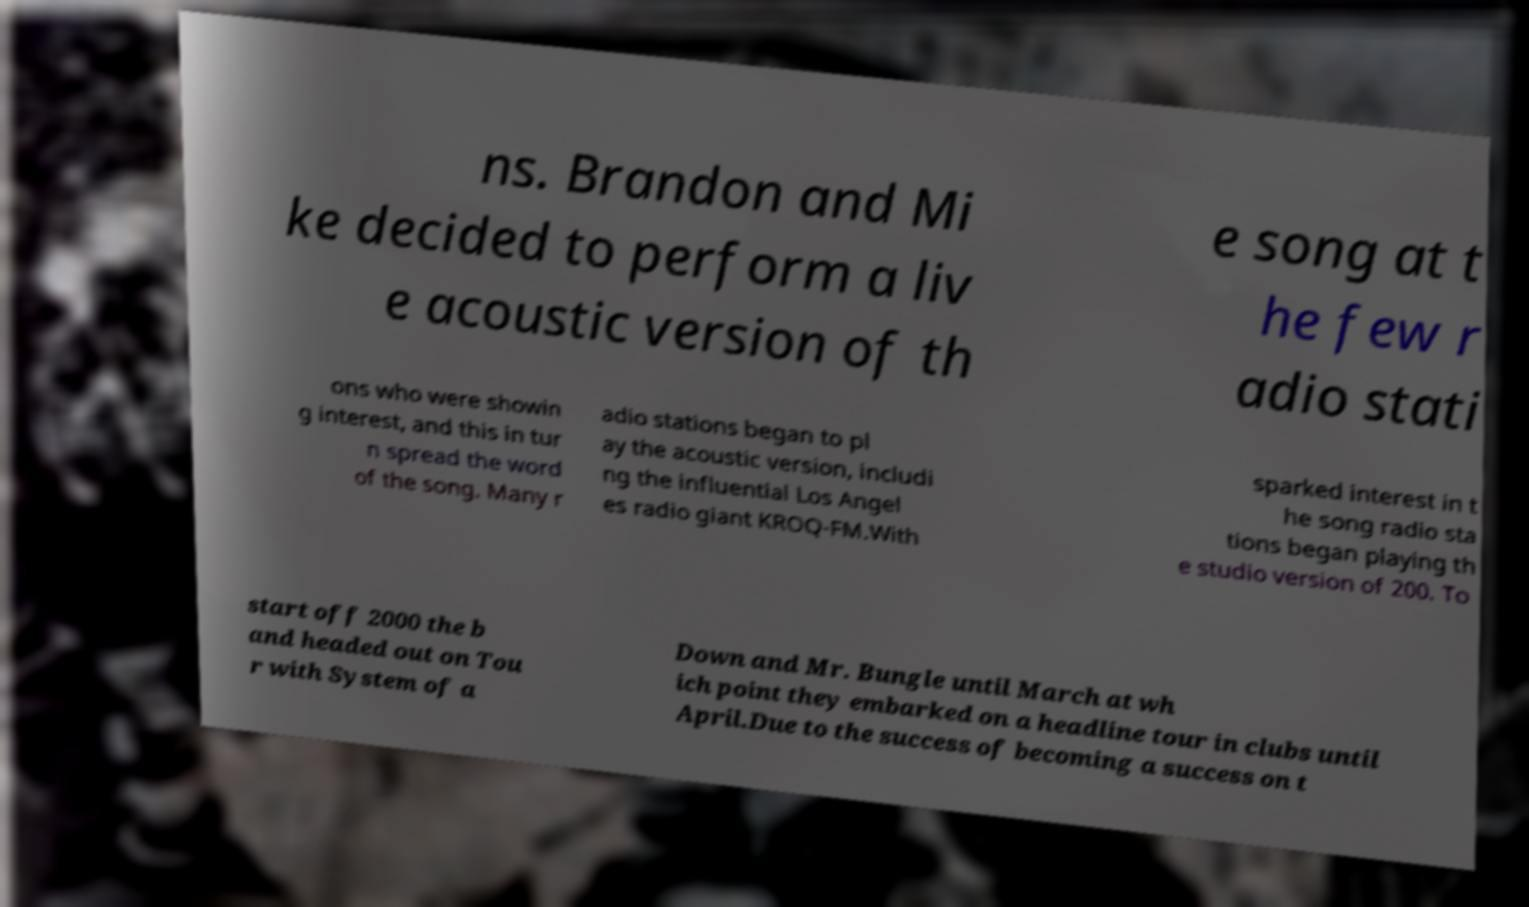I need the written content from this picture converted into text. Can you do that? ns. Brandon and Mi ke decided to perform a liv e acoustic version of th e song at t he few r adio stati ons who were showin g interest, and this in tur n spread the word of the song. Many r adio stations began to pl ay the acoustic version, includi ng the influential Los Angel es radio giant KROQ-FM.With sparked interest in t he song radio sta tions began playing th e studio version of 200. To start off 2000 the b and headed out on Tou r with System of a Down and Mr. Bungle until March at wh ich point they embarked on a headline tour in clubs until April.Due to the success of becoming a success on t 